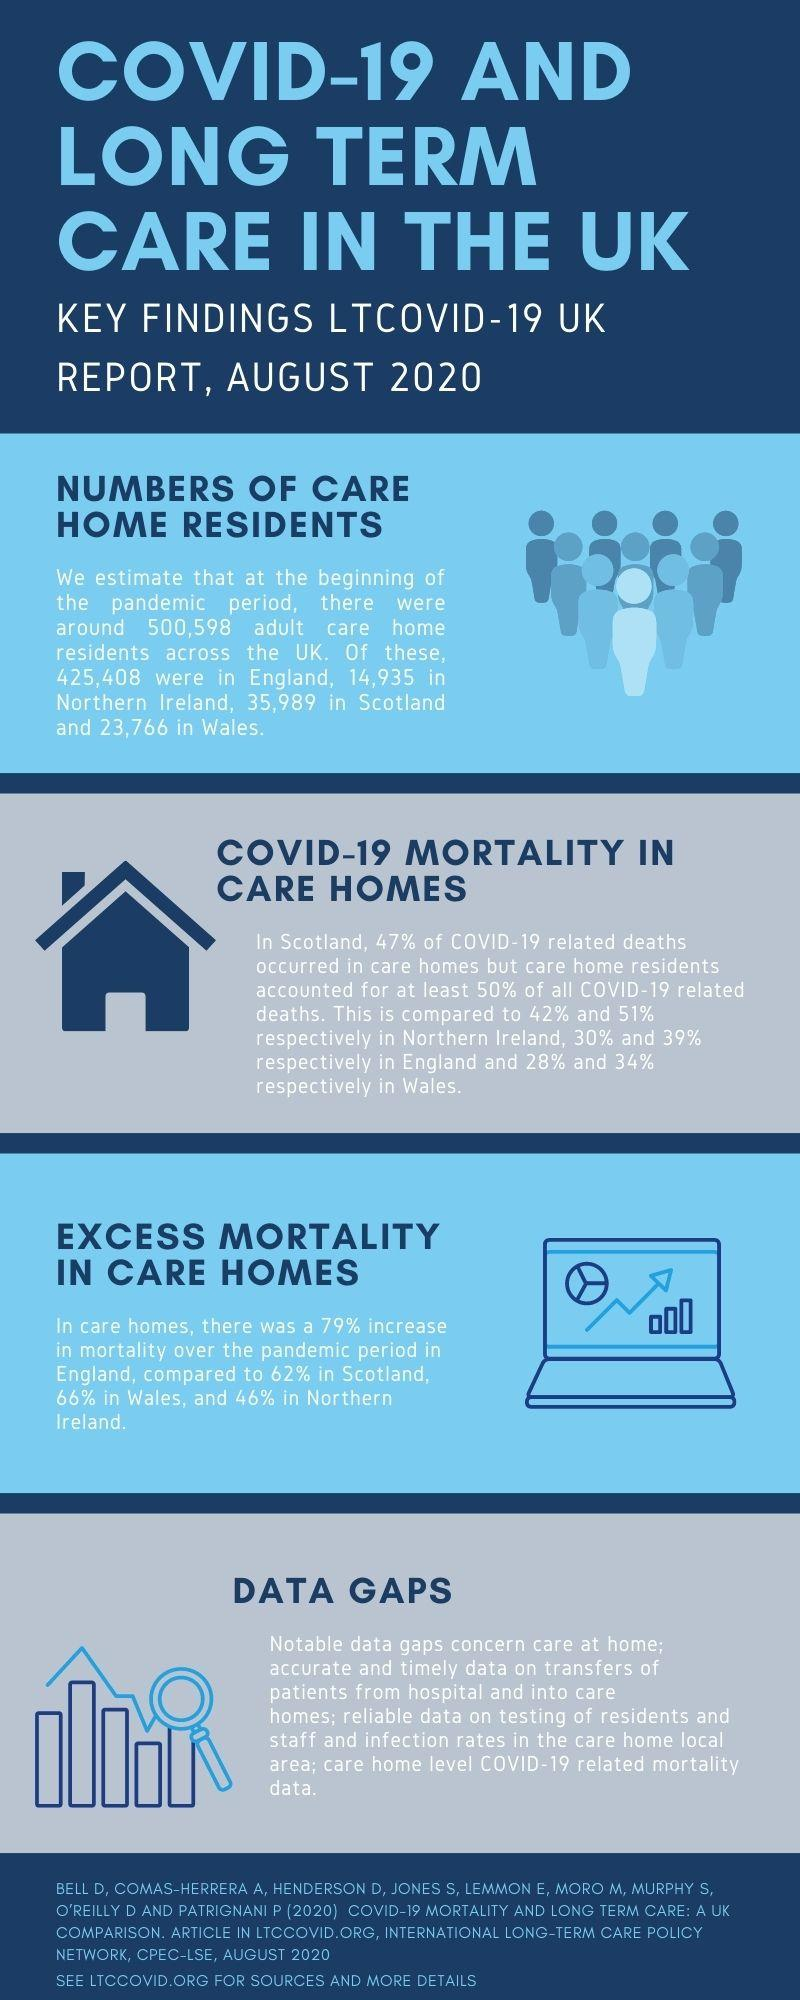Specify some key components in this picture. The percentage increase in mortality in England's care homes was 79%. In Northern Ireland, 51% of deaths were attributed to residents of care homes. 